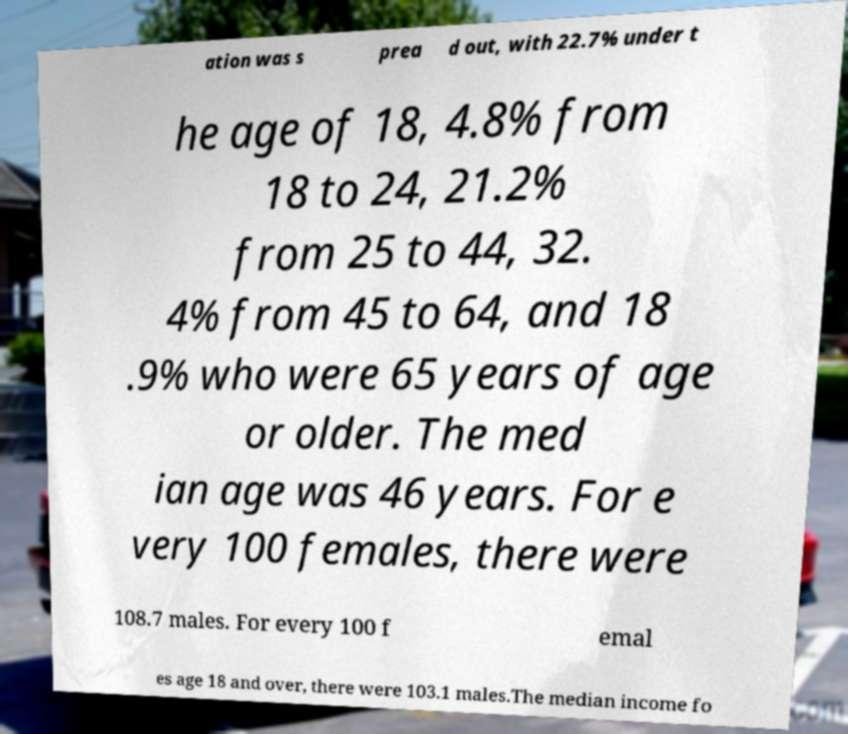For documentation purposes, I need the text within this image transcribed. Could you provide that? ation was s prea d out, with 22.7% under t he age of 18, 4.8% from 18 to 24, 21.2% from 25 to 44, 32. 4% from 45 to 64, and 18 .9% who were 65 years of age or older. The med ian age was 46 years. For e very 100 females, there were 108.7 males. For every 100 f emal es age 18 and over, there were 103.1 males.The median income fo 